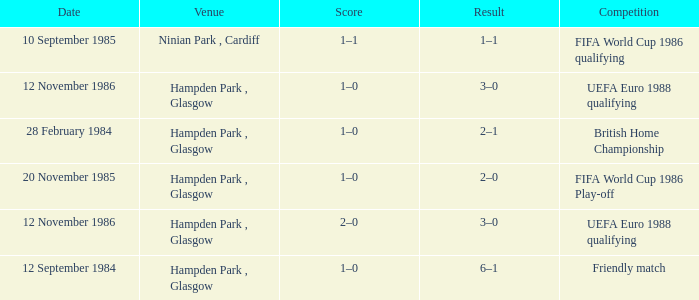What is the Date of the Competition with a Result of 3–0? 12 November 1986, 12 November 1986. 